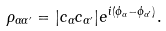<formula> <loc_0><loc_0><loc_500><loc_500>\rho _ { \alpha \alpha ^ { \prime } } = | c _ { \alpha } c _ { \alpha ^ { \prime } } | e ^ { i ( \phi _ { \alpha } - \phi _ { \alpha ^ { \prime } } ) } .</formula> 